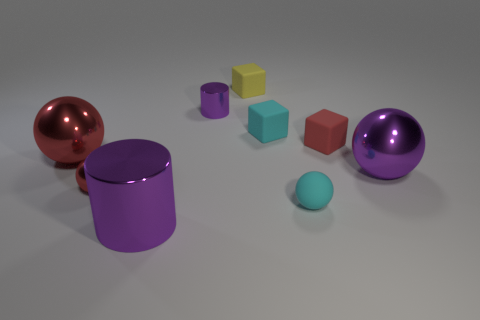How do the textures of the objects differ amongst themselves? The objects display varying textures: the spheres exhibit a glossy finish reflecting light vividly, the cylinders have a smooth matte finish, and the cubes appear less reflective and flatter in texture, suggesting they might have a more satiny or subdued finish. 